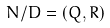<formula> <loc_0><loc_0><loc_500><loc_500>N / D = ( Q , R )</formula> 